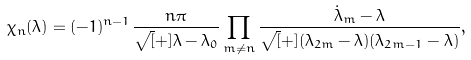Convert formula to latex. <formula><loc_0><loc_0><loc_500><loc_500>\chi _ { n } ( \lambda ) = ( - 1 ) ^ { n - 1 } \frac { n \pi } { \sqrt { [ } + ] { \lambda - \lambda _ { 0 } } } \prod _ { m \neq n } \frac { \dot { \lambda } _ { m } - \lambda } { \sqrt { [ } + ] { ( \lambda _ { 2 m } - \lambda ) ( \lambda _ { 2 m - 1 } - \lambda ) } } ,</formula> 